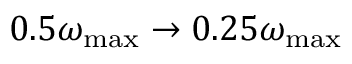Convert formula to latex. <formula><loc_0><loc_0><loc_500><loc_500>0 . 5 \omega _ { \max } \to 0 . 2 5 \omega _ { \max }</formula> 